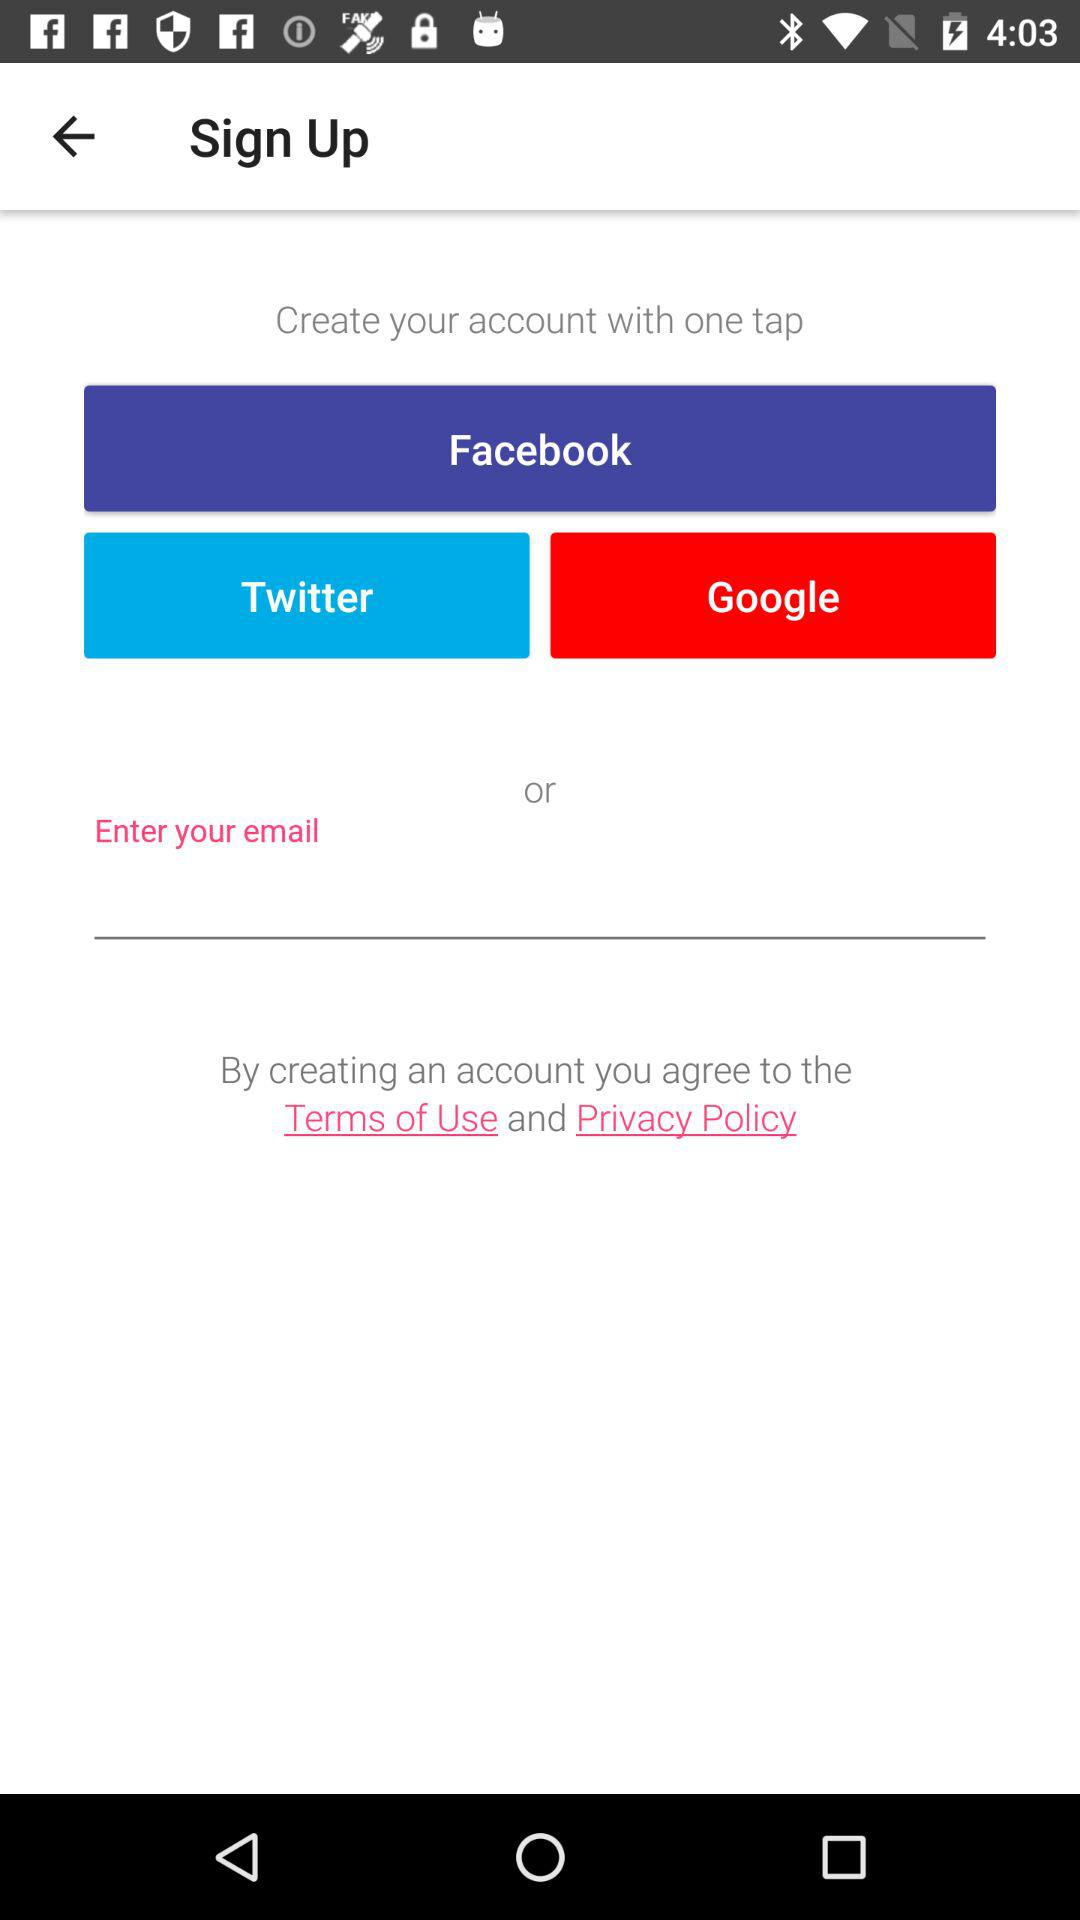What are the sign up options? The sign up options are: "Facebook", "Twitter", and "Google". 